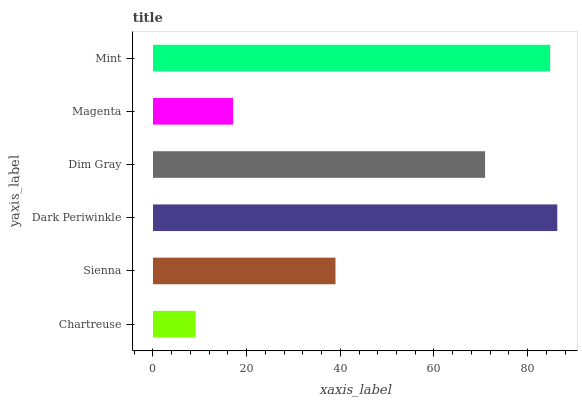Is Chartreuse the minimum?
Answer yes or no. Yes. Is Dark Periwinkle the maximum?
Answer yes or no. Yes. Is Sienna the minimum?
Answer yes or no. No. Is Sienna the maximum?
Answer yes or no. No. Is Sienna greater than Chartreuse?
Answer yes or no. Yes. Is Chartreuse less than Sienna?
Answer yes or no. Yes. Is Chartreuse greater than Sienna?
Answer yes or no. No. Is Sienna less than Chartreuse?
Answer yes or no. No. Is Dim Gray the high median?
Answer yes or no. Yes. Is Sienna the low median?
Answer yes or no. Yes. Is Sienna the high median?
Answer yes or no. No. Is Mint the low median?
Answer yes or no. No. 